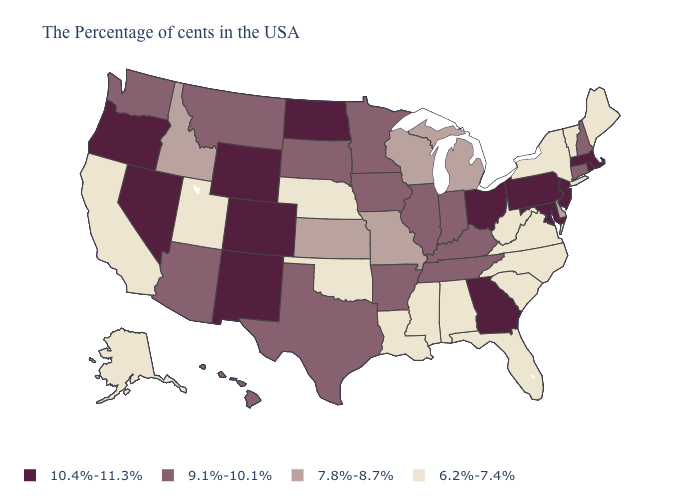What is the highest value in the West ?
Write a very short answer. 10.4%-11.3%. Does Indiana have the same value as Kentucky?
Write a very short answer. Yes. Does Ohio have the highest value in the MidWest?
Keep it brief. Yes. Name the states that have a value in the range 9.1%-10.1%?
Write a very short answer. New Hampshire, Connecticut, Kentucky, Indiana, Tennessee, Illinois, Arkansas, Minnesota, Iowa, Texas, South Dakota, Montana, Arizona, Washington, Hawaii. Which states hav the highest value in the Northeast?
Be succinct. Massachusetts, Rhode Island, New Jersey, Pennsylvania. Name the states that have a value in the range 10.4%-11.3%?
Quick response, please. Massachusetts, Rhode Island, New Jersey, Maryland, Pennsylvania, Ohio, Georgia, North Dakota, Wyoming, Colorado, New Mexico, Nevada, Oregon. Among the states that border Pennsylvania , which have the lowest value?
Write a very short answer. New York, West Virginia. Does Illinois have the highest value in the USA?
Concise answer only. No. Which states hav the highest value in the South?
Answer briefly. Maryland, Georgia. Among the states that border New Mexico , does Texas have the lowest value?
Keep it brief. No. Name the states that have a value in the range 10.4%-11.3%?
Answer briefly. Massachusetts, Rhode Island, New Jersey, Maryland, Pennsylvania, Ohio, Georgia, North Dakota, Wyoming, Colorado, New Mexico, Nevada, Oregon. Name the states that have a value in the range 9.1%-10.1%?
Concise answer only. New Hampshire, Connecticut, Kentucky, Indiana, Tennessee, Illinois, Arkansas, Minnesota, Iowa, Texas, South Dakota, Montana, Arizona, Washington, Hawaii. What is the highest value in the USA?
Concise answer only. 10.4%-11.3%. Name the states that have a value in the range 7.8%-8.7%?
Quick response, please. Delaware, Michigan, Wisconsin, Missouri, Kansas, Idaho. What is the lowest value in the USA?
Write a very short answer. 6.2%-7.4%. 